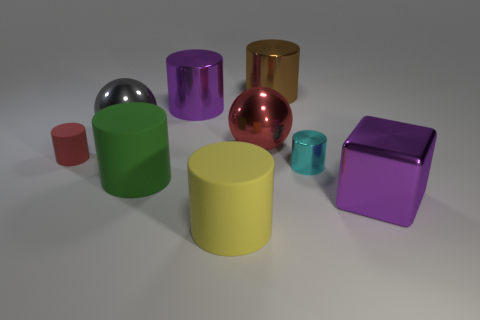Add 1 yellow shiny cylinders. How many objects exist? 10 Subtract all big metallic cylinders. How many cylinders are left? 4 Subtract all yellow cylinders. How many cylinders are left? 5 Subtract 1 cylinders. How many cylinders are left? 5 Subtract all blocks. How many objects are left? 8 Subtract all yellow cylinders. Subtract all gray spheres. How many cylinders are left? 5 Subtract all small metal cylinders. Subtract all cyan things. How many objects are left? 7 Add 9 small red objects. How many small red objects are left? 10 Add 2 brown cylinders. How many brown cylinders exist? 3 Subtract 0 green cubes. How many objects are left? 9 